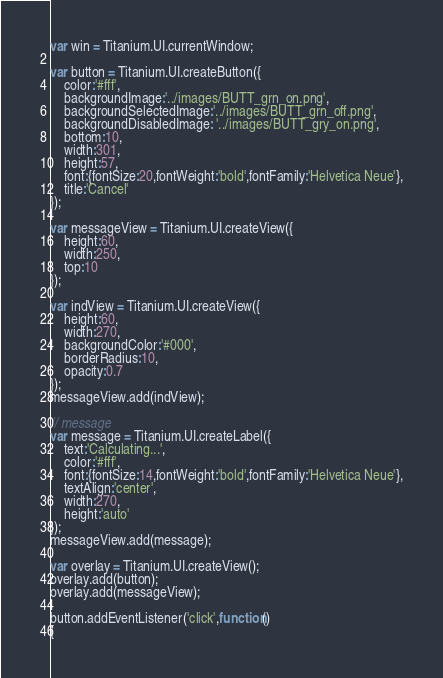Convert code to text. <code><loc_0><loc_0><loc_500><loc_500><_JavaScript_>var win = Titanium.UI.currentWindow;

var button = Titanium.UI.createButton({
	color:'#fff',
	backgroundImage:'../images/BUTT_grn_on.png',
	backgroundSelectedImage:'../images/BUTT_grn_off.png',
	backgroundDisabledImage: '../images/BUTT_gry_on.png',
	bottom:10,
	width:301,
	height:57,
	font:{fontSize:20,fontWeight:'bold',fontFamily:'Helvetica Neue'},
	title:'Cancel'
});

var messageView = Titanium.UI.createView({
	height:60,
	width:250,
	top:10
});

var indView = Titanium.UI.createView({
	height:60,
	width:270,
	backgroundColor:'#000',
	borderRadius:10,
	opacity:0.7
});
messageView.add(indView);

// message
var message = Titanium.UI.createLabel({
	text:'Calculating...',
	color:'#fff',
	font:{fontSize:14,fontWeight:'bold',fontFamily:'Helvetica Neue'},
	textAlign:'center',
	width:270,
	height:'auto'
});
messageView.add(message);

var overlay = Titanium.UI.createView();
overlay.add(button);
overlay.add(messageView);

button.addEventListener('click',function()
{</code> 